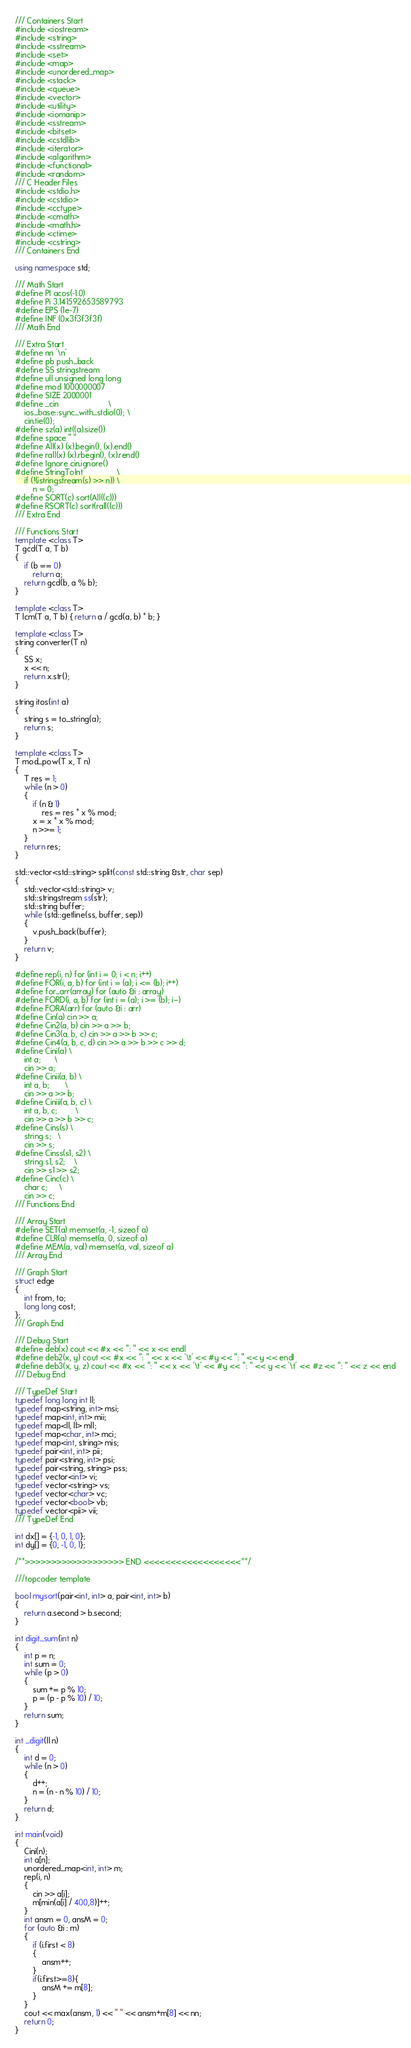<code> <loc_0><loc_0><loc_500><loc_500><_C++_>/// Containers Start
#include <iostream>
#include <string>
#include <sstream>
#include <set>
#include <map>
#include <unordered_map>
#include <stack>
#include <queue>
#include <vector>
#include <utility>
#include <iomanip>
#include <sstream>
#include <bitset>
#include <cstdlib>
#include <iterator>
#include <algorithm>
#include <functional>
#include <random>
/// C Header Files
#include <stdio.h>
#include <cstdio>
#include <cctype>
#include <cmath>
#include <math.h>
#include <ctime>
#include <cstring>
/// Containers End

using namespace std;

/// Math Start
#define PI acos(-1.0)
#define Pi 3.141592653589793
#define EPS (1e-7)
#define INF (0x3f3f3f3f)
/// Math End

/// Extra Start
#define nn '\n'
#define pb push_back
#define SS stringstream
#define ull unsigned long long
#define mod 1000000007
#define SIZE 2000001
#define _cin                      \
    ios_base::sync_with_stdio(0); \
    cin.tie(0);
#define sz(a) int((a).size())
#define space " "
#define All(x) (x).begin(), (x).end()
#define rall(x) (x).rbegin(), (x).rend()
#define Ignore cin.ignore()
#define StringToInt               \
    if (!(istringstream(s) >> n)) \
        n = 0;
#define SORT(c) sort(All((c)))
#define RSORT(c) sort(rall((c)))
/// Extra End

/// Functions Start
template <class T>
T gcd(T a, T b)
{
    if (b == 0)
        return a;
    return gcd(b, a % b);
}

template <class T>
T lcm(T a, T b) { return a / gcd(a, b) * b; }

template <class T>
string converter(T n)
{
    SS x;
    x << n;
    return x.str();
}

string itos(int a)
{
    string s = to_string(a);
    return s;
}

template <class T>
T mod_pow(T x, T n)
{
    T res = 1;
    while (n > 0)
    {
        if (n & 1)
            res = res * x % mod;
        x = x * x % mod;
        n >>= 1;
    }
    return res;
}

std::vector<std::string> split(const std::string &str, char sep)
{
    std::vector<std::string> v;
    std::stringstream ss(str);
    std::string buffer;
    while (std::getline(ss, buffer, sep))
    {
        v.push_back(buffer);
    }
    return v;
}

#define rep(i, n) for (int i = 0; i < n; i++)
#define FOR(i, a, b) for (int i = (a); i <= (b); i++)
#define for_arr(array) for (auto &i : array)
#define FORD(i, a, b) for (int i = (a); i >= (b); i--)
#define FORA(arr) for (auto &i : arr)
#define Cin(a) cin >> a;
#define Cin2(a, b) cin >> a >> b;
#define Cin3(a, b, c) cin >> a >> b >> c;
#define Cin4(a, b, c, d) cin >> a >> b >> c >> d;
#define Cini(a) \
    int a;      \
    cin >> a;
#define Cinii(a, b) \
    int a, b;       \
    cin >> a >> b;
#define Ciniii(a, b, c) \
    int a, b, c;        \
    cin >> a >> b >> c;
#define Cins(s) \
    string s;   \
    cin >> s;
#define Cinss(s1, s2) \
    string s1, s2;    \
    cin >> s1 >> s2;
#define Cinc(c) \
    char c;     \
    cin >> c;
/// Functions End

/// Array Start
#define SET(a) memset(a, -1, sizeof a)
#define CLR(a) memset(a, 0, sizeof a)
#define MEM(a, val) memset(a, val, sizeof a)
/// Array End

/// Graph Start
struct edge
{
    int from, to;
    long long cost;
};
/// Graph End

/// Debug Start
#define deb(x) cout << #x << ": " << x << endl
#define deb2(x, y) cout << #x << ": " << x << '\t' << #y << ": " << y << endl
#define deb3(x, y, z) cout << #x << ": " << x << '\t' << #y << ": " << y << '\t' << #z << ": " << z << end
/// Debug End

/// TypeDef Start
typedef long long int ll;
typedef map<string, int> msi;
typedef map<int, int> mii;
typedef map<ll, ll> mll;
typedef map<char, int> mci;
typedef map<int, string> mis;
typedef pair<int, int> pii;
typedef pair<string, int> psi;
typedef pair<string, string> pss;
typedef vector<int> vi;
typedef vector<string> vs;
typedef vector<char> vc;
typedef vector<bool> vb;
typedef vector<pii> vii;
/// TypeDef End

int dx[] = {-1, 0, 1, 0};
int dy[] = {0, -1, 0, 1};

/**>>>>>>>>>>>>>>>>>>> END <<<<<<<<<<<<<<<<<<**/

///topcoder template

bool mysort(pair<int, int> a, pair<int, int> b)
{
    return a.second > b.second;
}

int digit_sum(int n)
{
    int p = n;
    int sum = 0;
    while (p > 0)
    {
        sum += p % 10;
        p = (p - p % 10) / 10;
    }
    return sum;
}

int _digit(ll n)
{
    int d = 0;
    while (n > 0)
    {
        d++;
        n = (n - n % 10) / 10;
    }
    return d;
}

int main(void)
{
    Cini(n);
    int a[n];
    unordered_map<int, int> m;
    rep(i, n)
    {
        cin >> a[i];
        m[min(a[i] / 400,8)]++;
    }
    int ansm = 0, ansM = 0;
    for (auto &i : m)
    {
        if (i.first < 8)
        {
            ansm++;
        }
        if(i.first>=8){
            ansM += m[8];
        }
    }
    cout << max(ansm, 1) << " " << ansm+m[8] << nn;
    return 0;
}
</code> 